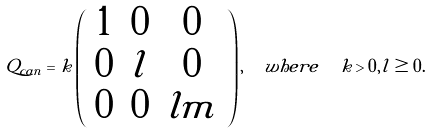<formula> <loc_0><loc_0><loc_500><loc_500>Q _ { c a n } = k \left ( \begin{array} { c c c } 1 & 0 & 0 \\ 0 & l & 0 \\ 0 & 0 & l m \end{array} \right ) , \ \ w h e r e \ \ k > 0 , l \geq 0 .</formula> 